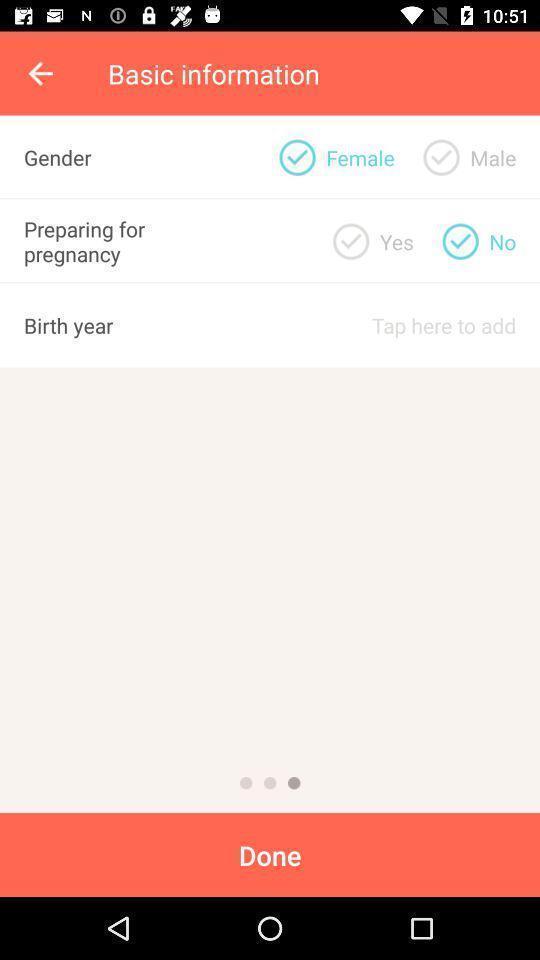Please provide a description for this image. Page shows to give the information for pregnancy app. 